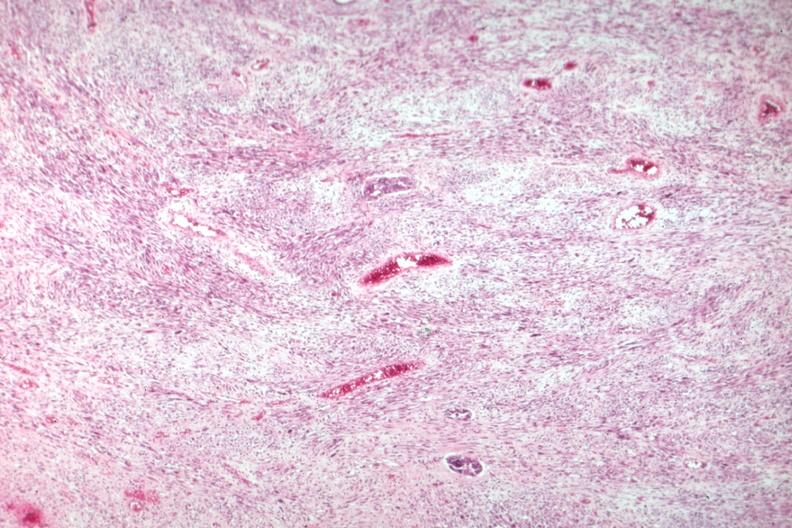s mixed mesodermal tumor present?
Answer the question using a single word or phrase. Yes 